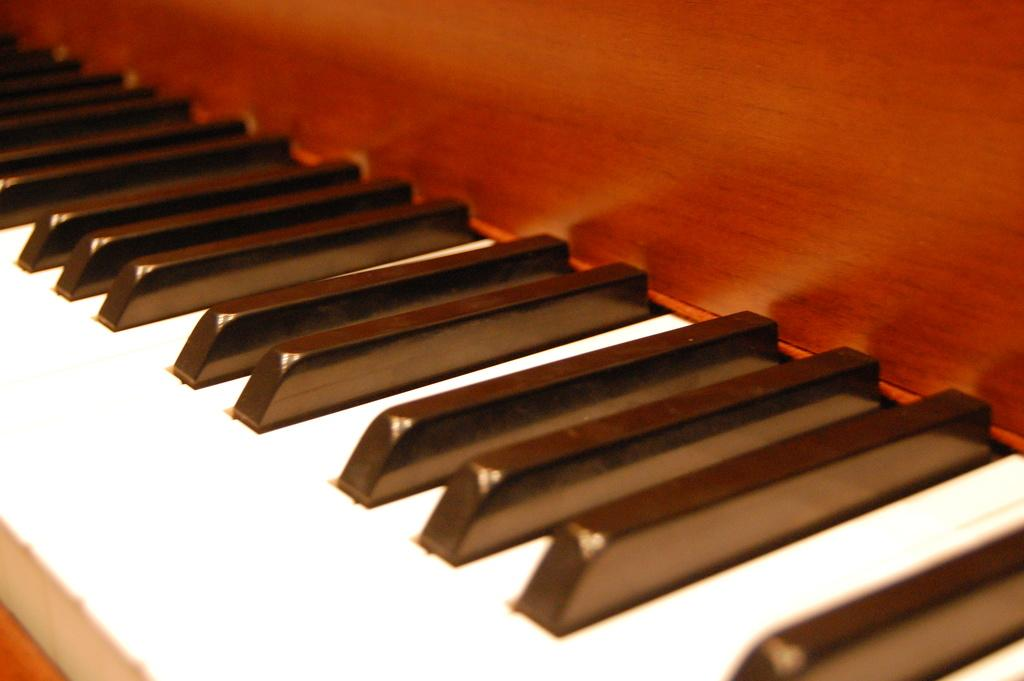What musical instrument is featured in the image? There is a piano keyboard in the image. What part of the piano is visible in the image? The piano keyboard is visible in the image. What type of pail is used to perform the operation on the person in the image? There is no pail, operation, or person present in the image; it only features a piano keyboard. 